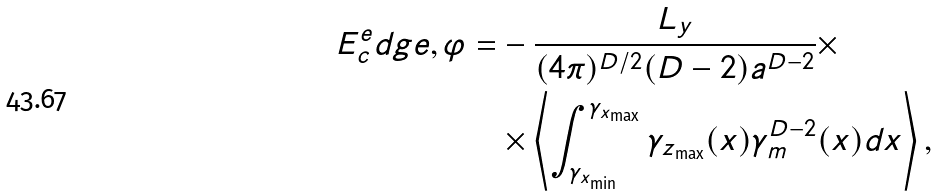<formula> <loc_0><loc_0><loc_500><loc_500>E _ { c } ^ { e } d g e , \varphi = & - \frac { L _ { y } } { ( 4 \pi ) ^ { D / 2 } ( D - 2 ) a ^ { D - 2 } } \times \\ & \times \left \langle \int _ { \gamma _ { x _ { \min } } } ^ { \gamma _ { x _ { \max } } } \gamma _ { z _ { \max } } ( x ) \gamma _ { m } ^ { D - 2 } ( x ) d x \right \rangle ,</formula> 